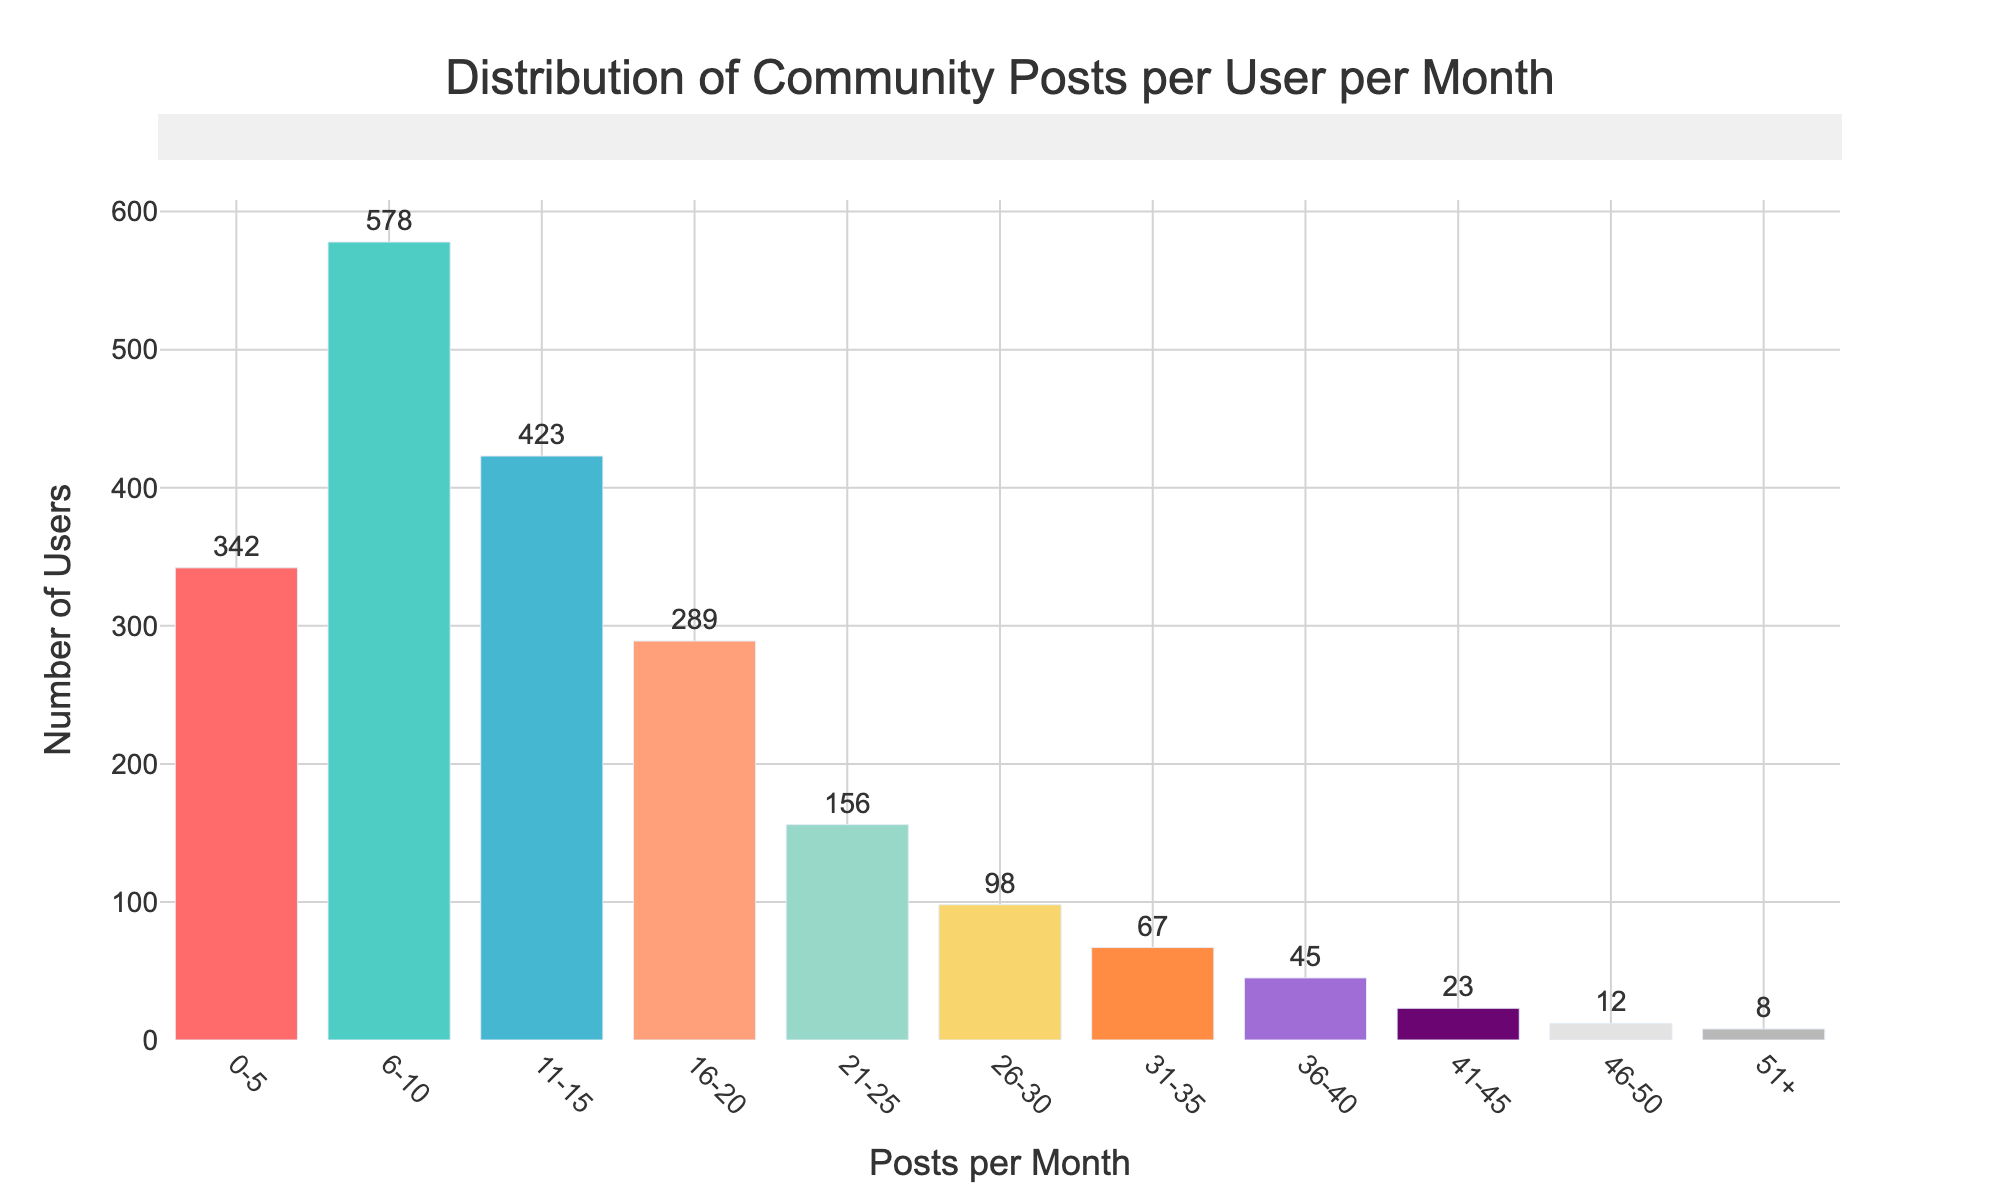What's the title of the figure? The title is placed at the top center of the figure. It reads 'Distribution of Community Posts per User per Month'.
Answer: Distribution of Community Posts per User per Month How many users posted between 6 and 10 times per month? The bar corresponding to the range '6-10' on the x-axis shows the number of users written above the bar. The value is 578.
Answer: 578 Which range has the least number of users? By observing the heights of the bars, the range with the shortest bar represents the least number of users. The shortest bar corresponds to the '51+' range.
Answer: 51+ How many users posted more than 40 times in a month? Sum the values of the bars from the ranges '41-45', '46-50', and '51+'. The respective values are 23, 12, and 8. 23 + 12 + 8 = 43.
Answer: 43 Which range has more users, '11-15' or '21-25'? Compare the heights of the bars for '11-15' and '21-25' ranges. The numbers above the bars show 423 users for '11-15' and 156 users for '21-25'.
Answer: 11-15 Are there more users posting 0-5 times or 16-20 times per month? Check the heights of the bars corresponding to the ranges '0-5' and '16-20'. The values are 342 for '0-5' and 289 for '16-20'.
Answer: 0-5 What's the total number of users who posted between 0 and 20 times per month? Sum the values of bars from ranges '0-5', '6-10', '11-15', and '16-20'. 342 + 578 + 423 + 289 = 1632.
Answer: 1632 Which range has the highest number of users? Identify the tallest bar in the histogram. The range '6-10' has the highest bar indicating 578 users.
Answer: 6-10 How does the number of users posting 26-30 times per month compare to those posting 31-35 times? Refer to the heights of the bars for '26-30' and '31-35'. The bars show 98 users for '26-30' and 67 users for '31-35'. 98 > 67.
Answer: More What's the difference in the number of users posting between 21-25 times and 46-50 times per month? Subtract the number of users in the '46-50' range from the '21-25' range. The bars show 156 users for '21-25' and 12 users for '46-50'. 156 - 12 = 144.
Answer: 144 